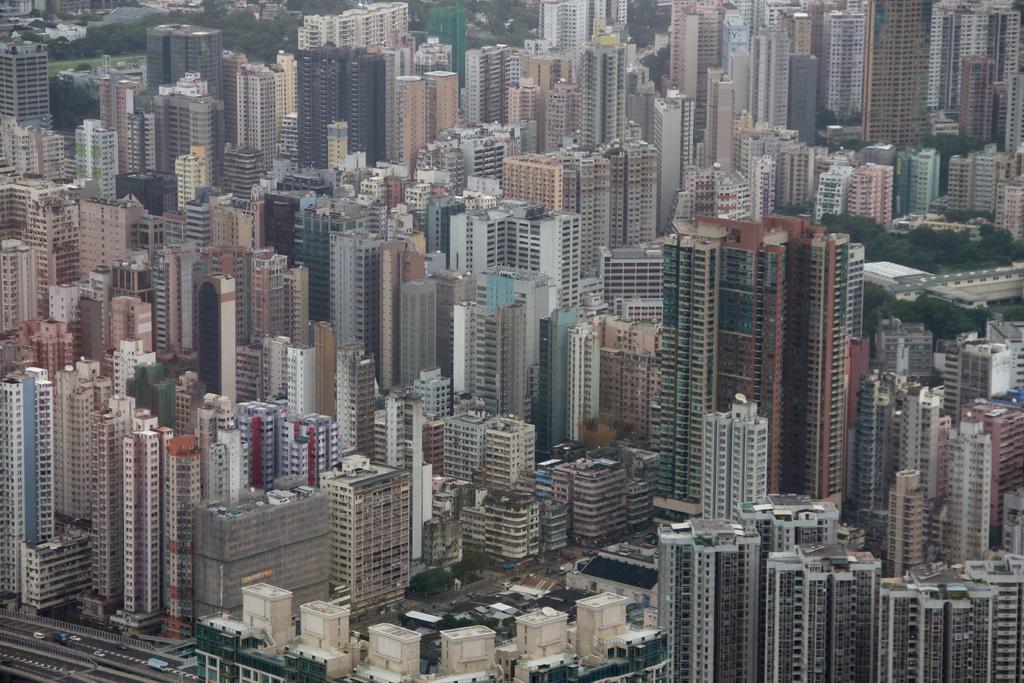Could you give a brief overview of what you see in this image? In this image we can see skyscrapers, buildings, trees, grounds and motor vehicles on the road. 